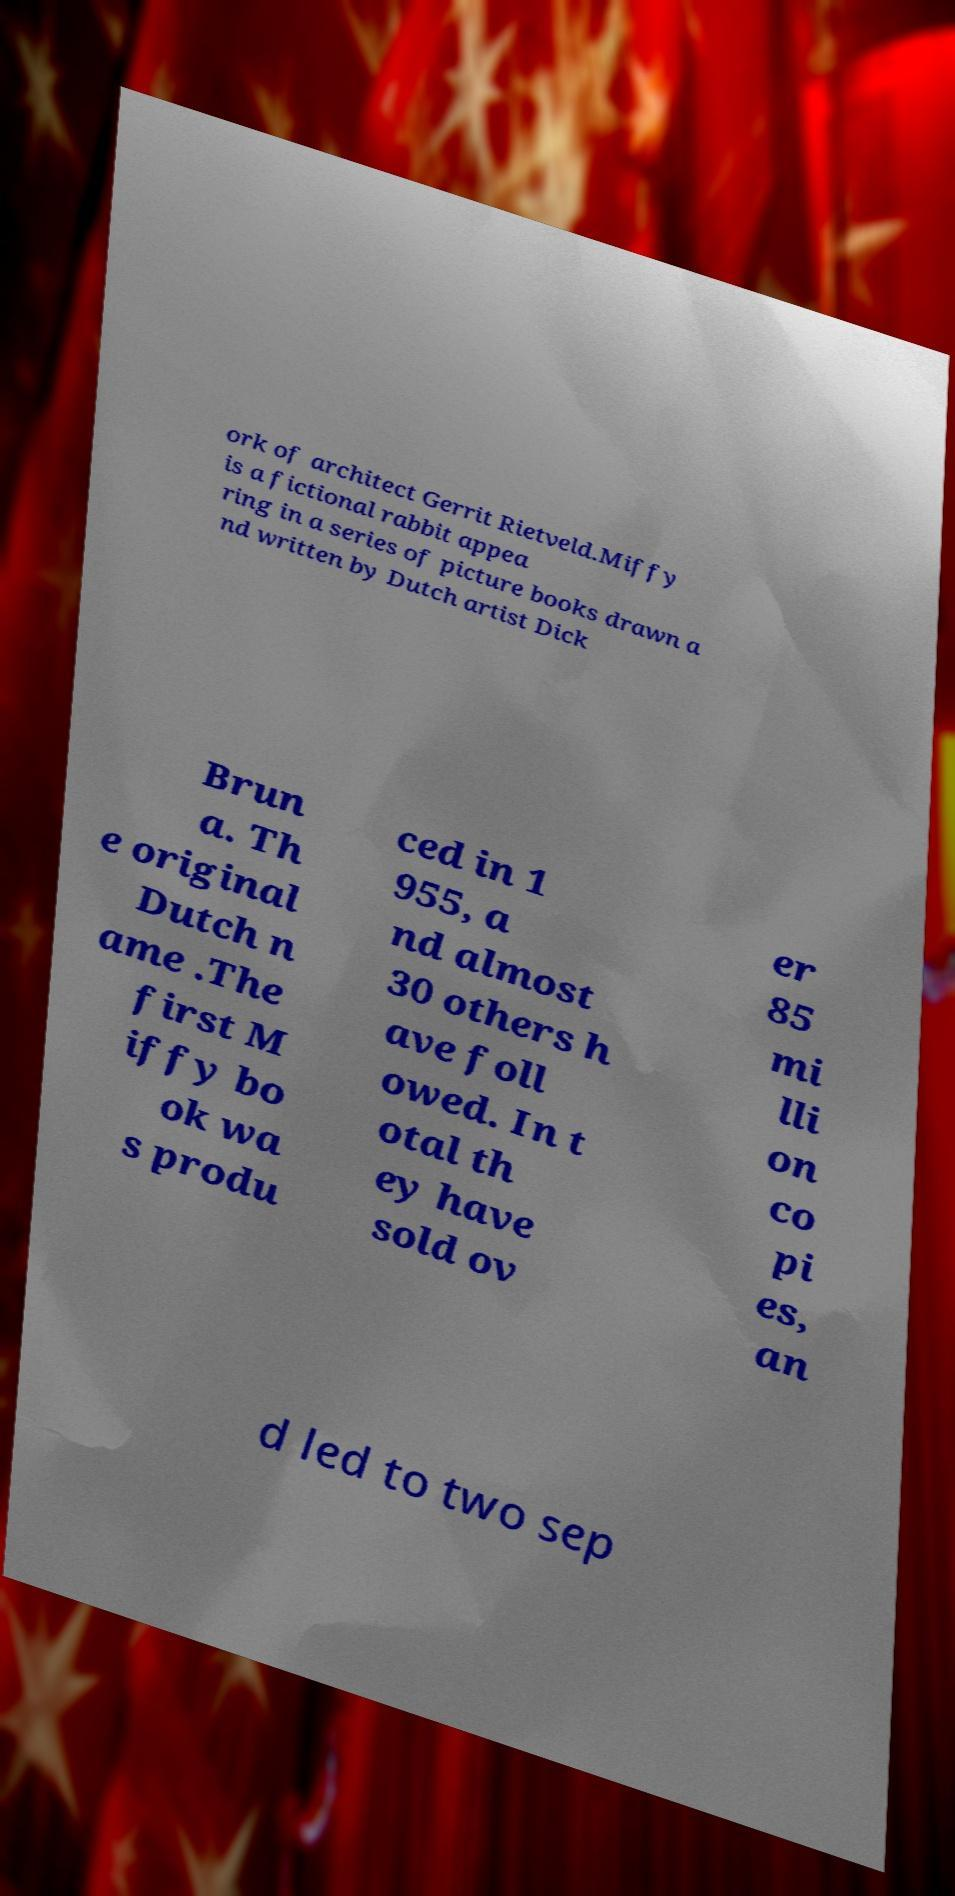For documentation purposes, I need the text within this image transcribed. Could you provide that? ork of architect Gerrit Rietveld.Miffy is a fictional rabbit appea ring in a series of picture books drawn a nd written by Dutch artist Dick Brun a. Th e original Dutch n ame .The first M iffy bo ok wa s produ ced in 1 955, a nd almost 30 others h ave foll owed. In t otal th ey have sold ov er 85 mi lli on co pi es, an d led to two sep 